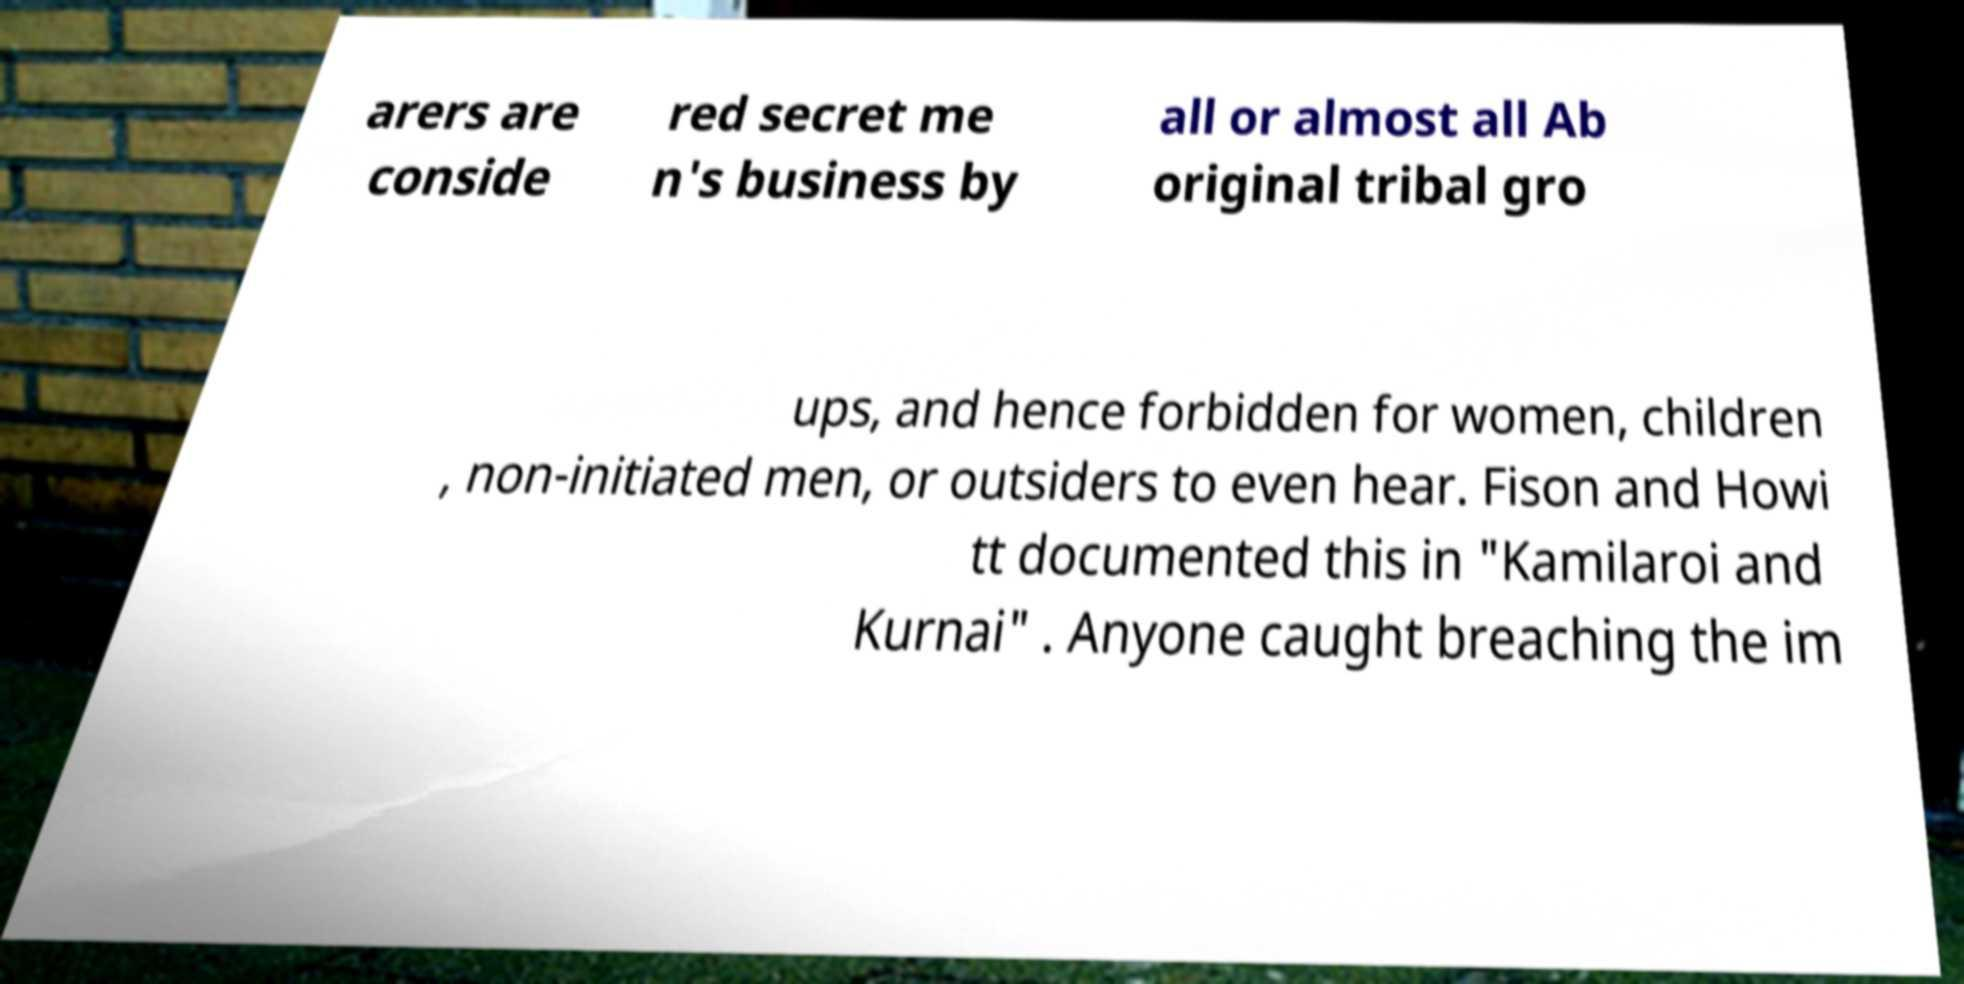Could you extract and type out the text from this image? arers are conside red secret me n's business by all or almost all Ab original tribal gro ups, and hence forbidden for women, children , non-initiated men, or outsiders to even hear. Fison and Howi tt documented this in "Kamilaroi and Kurnai" . Anyone caught breaching the im 